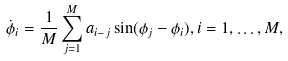<formula> <loc_0><loc_0><loc_500><loc_500>\dot { \phi } _ { i } = \frac { 1 } { M } \sum _ { j = 1 } ^ { M } a _ { i - j } \sin ( \phi _ { j } - \phi _ { i } ) , i = 1 , \dots , M ,</formula> 